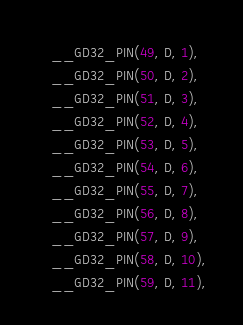<code> <loc_0><loc_0><loc_500><loc_500><_C_>    __GD32_PIN(49, D, 1),
    __GD32_PIN(50, D, 2),
    __GD32_PIN(51, D, 3),
    __GD32_PIN(52, D, 4),
    __GD32_PIN(53, D, 5),
    __GD32_PIN(54, D, 6),
    __GD32_PIN(55, D, 7),
    __GD32_PIN(56, D, 8),
    __GD32_PIN(57, D, 9),
    __GD32_PIN(58, D, 10),
    __GD32_PIN(59, D, 11),</code> 